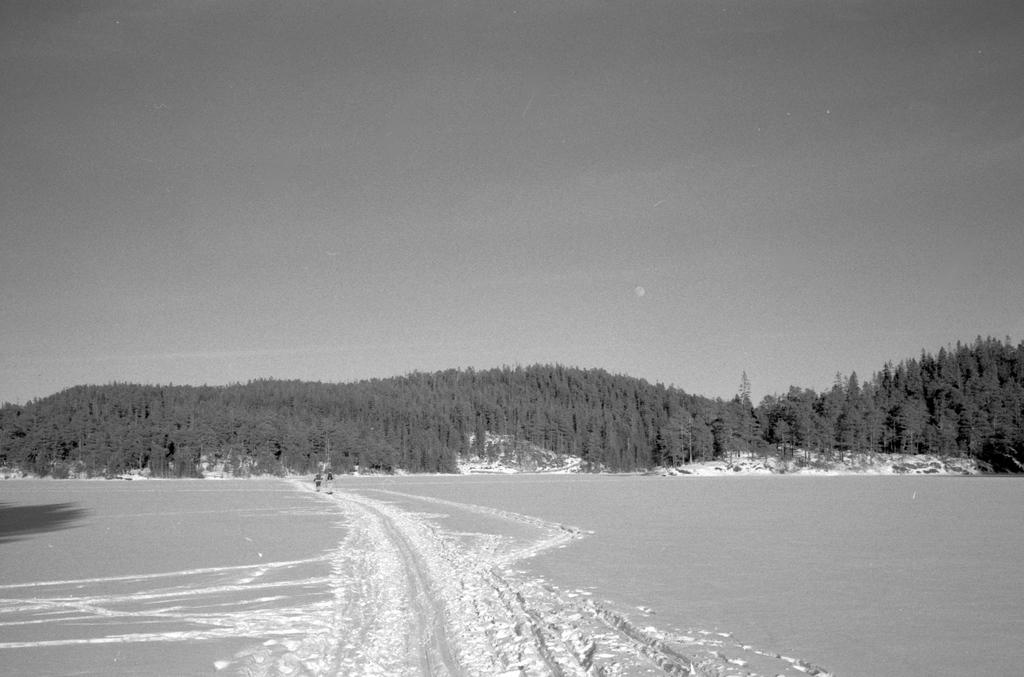What is the color scheme of the image? The image is black and white. What type of terrain can be seen in the image? There is ground visible in the image. What type of vegetation is present in the image? There are trees in the image. What part of the natural environment is visible in the image? The sky is visible in the image. How many cherries can be seen hanging from the tree in the image? There are no cherries present in the image; it only features trees without any fruit. What type of fiction is being read by the tree in the image? There is no tree reading any fiction in the image, as trees are not capable of reading. 